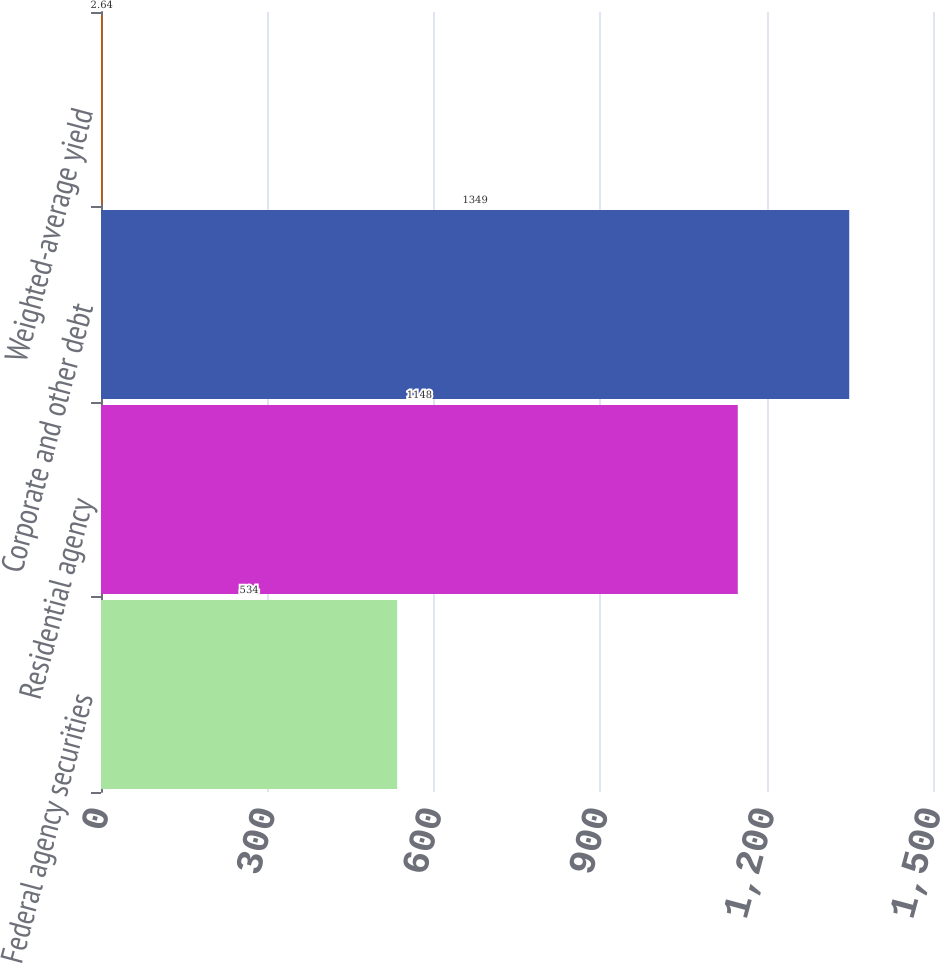Convert chart. <chart><loc_0><loc_0><loc_500><loc_500><bar_chart><fcel>Federal agency securities<fcel>Residential agency<fcel>Corporate and other debt<fcel>Weighted-average yield<nl><fcel>534<fcel>1148<fcel>1349<fcel>2.64<nl></chart> 